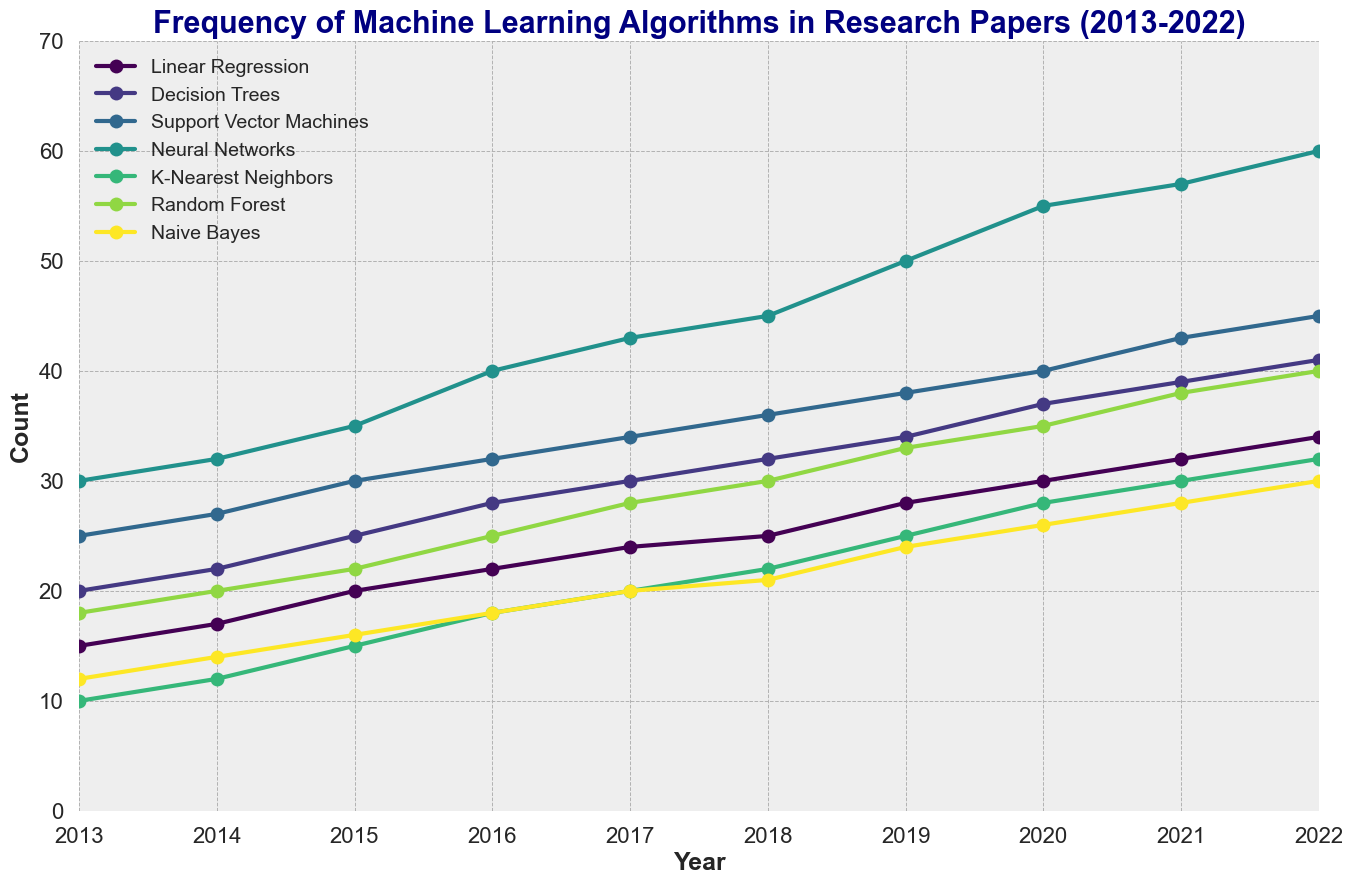Which algorithm had the highest frequency in 2022? Look at the algorithm with the highest count in the year 2022. Neural Networks had the highest frequency with a count of 60.
Answer: Neural Networks What was the trend in frequency of Decision Trees from 2013 to 2022? Observe the trend line for Decision Trees from the plot. The frequency increased steadily every year from 20 in 2013 to 41 in 2022.
Answer: Increased steadily How did the frequency of Support Vector Machines compare to Neural Networks in 2021? Compare the counts for Support Vector Machines and Neural Networks in 2021. Support Vector Machines had a count of 43 while Neural Networks had a count of 57, making Neural Networks more frequent.
Answer: Neural Networks more frequent What is the difference in frequency between Random Forest and Naive Bayes in 2020? Subtract the count of Naive Bayes from the count of Random Forest in 2020. Random Forest had a count of 35 and Naive Bayes had a count of 26, so the difference is 35 - 26 = 9.
Answer: 9 Which algorithm showed the fastest growth rate from 2013 to 2022? Determine the difference in counts for each algorithm between 2013 and 2022 and identify the one with the largest difference. Neural Networks grew from 30 in 2013 to 60 in 2022, a difference of 30, which is the highest among the algorithms.
Answer: Neural Networks What is the average count of K-Nearest Neighbors from 2013 to 2022? Calculate the mean of the counts of K-Nearest Neighbors from 2013 to 2022. The counts are 10, 12, 15, 18, 20, 22, 25, 28, 30, 32. Sum these values (10+12+15+18+20+22+25+28+30+32 = 212) and divide by 10 (years): 212/10 = 21.2.
Answer: 21.2 In which year did Neural Networks surpass the count of 50? Inspect the frequency of Neural Networks over the years and find the first year it went above 50. In 2019, Neural Networks had a count of 50, and in 2020 it surpassed 50 with a count of 55.
Answer: 2020 Which algorithm had the lowest count in 2015, and what was the count? Look at the count for each algorithm in 2015 and identify the lowest one. K-Nearest Neighbors had the lowest count with 15.
Answer: K-Nearest Neighbors, 15 How does the frequency change of Linear Regression from 2013 to 2022 compare to that of Random Forest? Calculate the frequency change for both algorithms from 2013 to 2022 by subtracting the 2013 count from the 2022 count. Linear Regression increased from 15 to 34 (19). Random Forest increased from 18 to 40 (22). Random Forest had a higher change (22 vs 19).
Answer: Random Forest had a higher change 